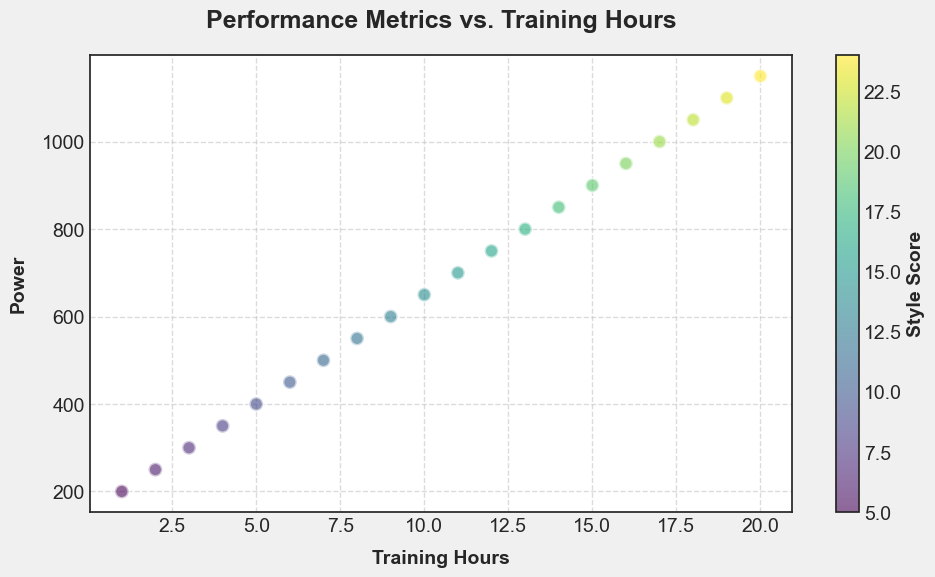What is the relationship between Training Hours and Power? As Training Hours increase, the Power also increases. This is evident by the upward trend in the scatter plot where higher Training Hours are associated with higher Power values.
Answer: Positive correlation Which data point has the highest Power value? The data point with the highest Power value has a Power of 1150 and corresponds to 20 Training Hours. This is seen as the point at the far-right end of the scatter plot.
Answer: Point with 20 Training Hours What range of Training Hours corresponds to a Style Score of 10 to 15? The Style Scores of 10 to 15 correspond to Training Hours between 6 and 11. This is indicated by the colors in the scatter plot within the range of Style Scores from 10 to 15.
Answer: 6 to 11 Training Hours How does the Style Score change as Power increases? As Power increases, the Style Score also increases. This is observed from the gradient color scheme where lower Power values have darker colors, and higher Power values have lighter colors.
Answer: Increases What is the Style Score for the data point with 8 Training Hours? The Style Score for the data point with 8 Training Hours is 12. This can be identified from the color bar and the color of the scatter point at 8 Training Hours.
Answer: 12 What is the difference in Power between 10 and 15 Training Hours? The Power value at 10 Training Hours is 650, and at 15 Training Hours is 900. The difference in Power between these two points is 900 - 650 = 250.
Answer: 250 Which Training Hour point has the lowest Power and what is its Style Score? The lowest Power value is 200, which corresponds to 1 Training Hour. Its Style Score is 5, indicated by the color depicted, which matches the color bar.
Answer: 1 Training Hour, Style Score 5 Is there any outlier or noticeable deviation in the plot? No, there is no noticeable outlier or deviation in the plot. All data points follow a linear trend where higher Training Hours correlate with higher Power and increasing Style Score.
Answer: No outliers If the Training Hours are doubled from 5 to 10, how much does the Power increase? The Power at 5 Training Hours is 400, and at 10 Training Hours is 650. Doubling the Training Hours results in an increase of 650 - 400 = 250 in Power.
Answer: 250 